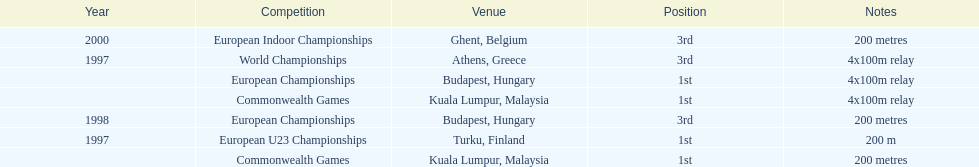Would you be able to parse every entry in this table? {'header': ['Year', 'Competition', 'Venue', 'Position', 'Notes'], 'rows': [['2000', 'European Indoor Championships', 'Ghent, Belgium', '3rd', '200 metres'], ['1997', 'World Championships', 'Athens, Greece', '3rd', '4x100m relay'], ['', 'European Championships', 'Budapest, Hungary', '1st', '4x100m relay'], ['', 'Commonwealth Games', 'Kuala Lumpur, Malaysia', '1st', '4x100m relay'], ['1998', 'European Championships', 'Budapest, Hungary', '3rd', '200 metres'], ['1997', 'European U23 Championships', 'Turku, Finland', '1st', '200 m'], ['', 'Commonwealth Games', 'Kuala Lumpur, Malaysia', '1st', '200 metres']]} List the other competitions besides european u23 championship that came in 1st position? European Championships, Commonwealth Games, Commonwealth Games. 